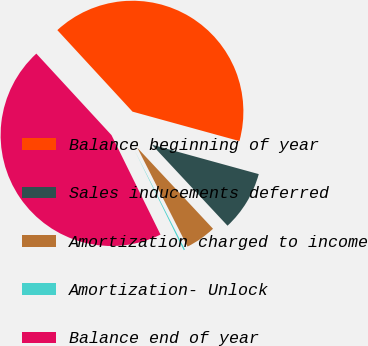Convert chart to OTSL. <chart><loc_0><loc_0><loc_500><loc_500><pie_chart><fcel>Balance beginning of year<fcel>Sales inducements deferred<fcel>Amortization charged to income<fcel>Amortization- Unlock<fcel>Balance end of year<nl><fcel>41.13%<fcel>8.77%<fcel>4.48%<fcel>0.19%<fcel>45.43%<nl></chart> 